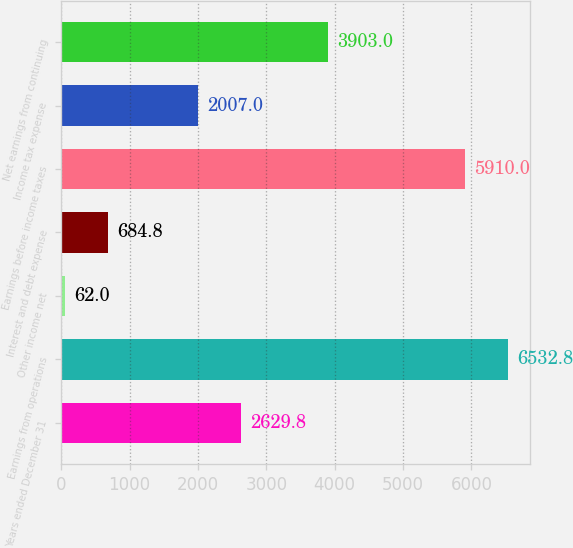Convert chart. <chart><loc_0><loc_0><loc_500><loc_500><bar_chart><fcel>Years ended December 31<fcel>Earnings from operations<fcel>Other income net<fcel>Interest and debt expense<fcel>Earnings before income taxes<fcel>Income tax expense<fcel>Net earnings from continuing<nl><fcel>2629.8<fcel>6532.8<fcel>62<fcel>684.8<fcel>5910<fcel>2007<fcel>3903<nl></chart> 